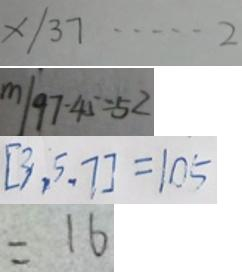Convert formula to latex. <formula><loc_0><loc_0><loc_500><loc_500>x / 3 7 \cdots 2 
 m / 9 7 - 4 5 = 5 2 
 [ 3 , 5 , 7 ] = 1 0 5 
 = 1 6</formula> 